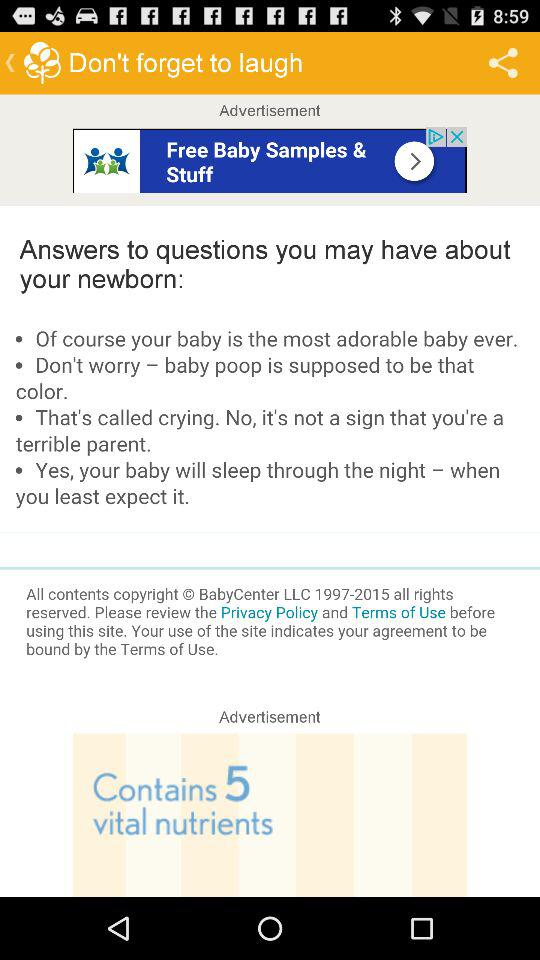What is the application name? The application name is "BabyCenter My Pregnancy Today". 